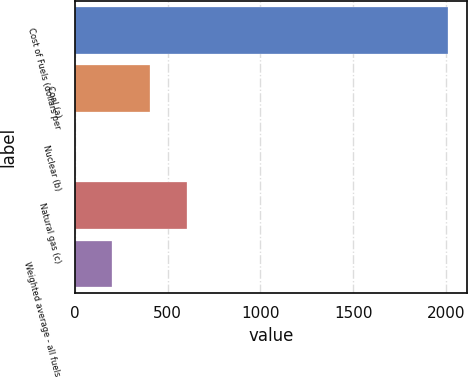Convert chart. <chart><loc_0><loc_0><loc_500><loc_500><bar_chart><fcel>Cost of Fuels (dollars per<fcel>Coal (a)<fcel>Nuclear (b)<fcel>Natural gas (c)<fcel>Weighted average - all fuels<nl><fcel>2013<fcel>403.36<fcel>0.94<fcel>604.57<fcel>202.15<nl></chart> 